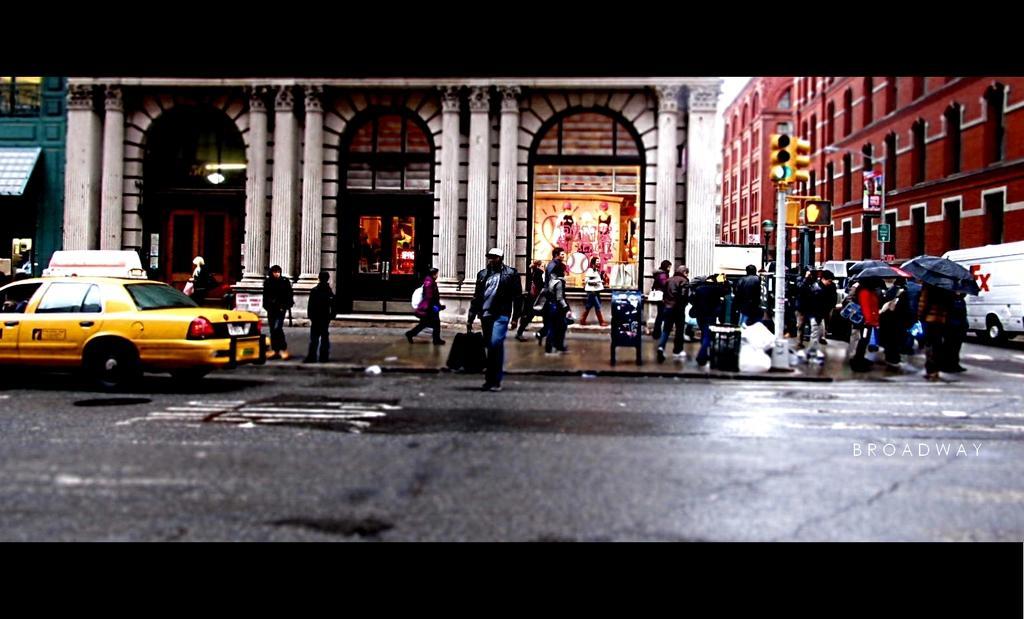Please provide a concise description of this image. This picture describe about the view of the roadside. In front there is a yellow color taxi. Behind there is a white arch building with big pillar. On the right side we can see some persons standing and holding the umbrella waiting on the zebra crossing. 